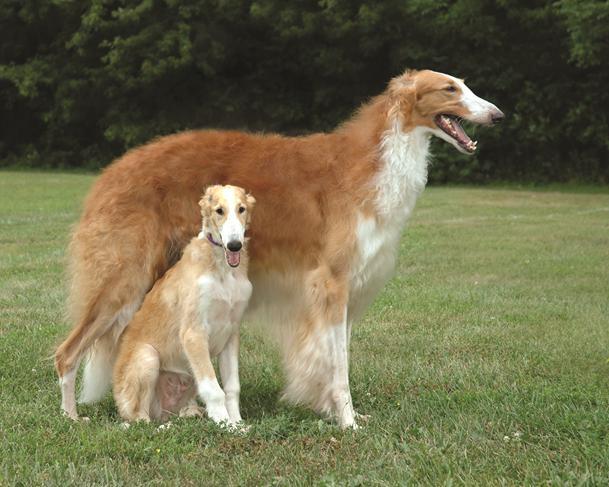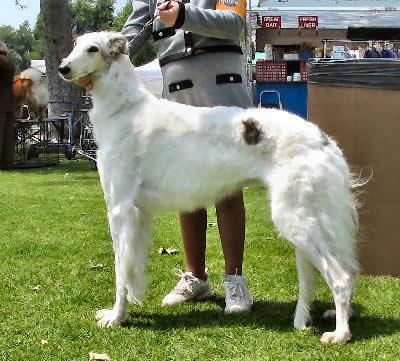The first image is the image on the left, the second image is the image on the right. For the images shown, is this caption "An image shows one hound standing in profile with body turned leftward, on green grass in front of a manmade structure." true? Answer yes or no. Yes. The first image is the image on the left, the second image is the image on the right. Considering the images on both sides, is "There are three hounds on the grass in total." valid? Answer yes or no. Yes. 